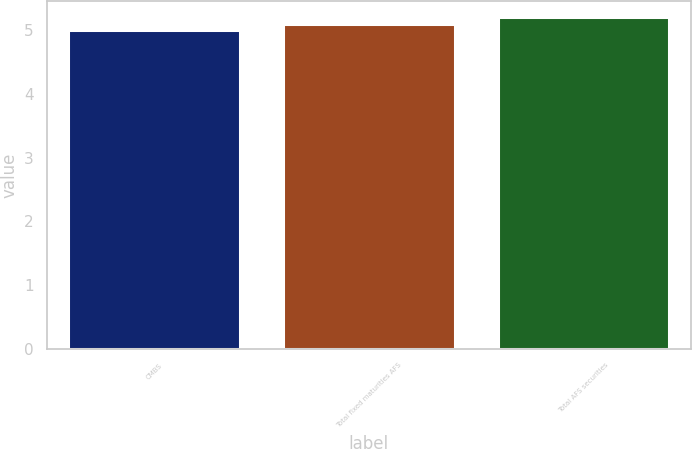<chart> <loc_0><loc_0><loc_500><loc_500><bar_chart><fcel>CMBS<fcel>Total fixed maturities AFS<fcel>Total AFS securities<nl><fcel>5<fcel>5.1<fcel>5.2<nl></chart> 